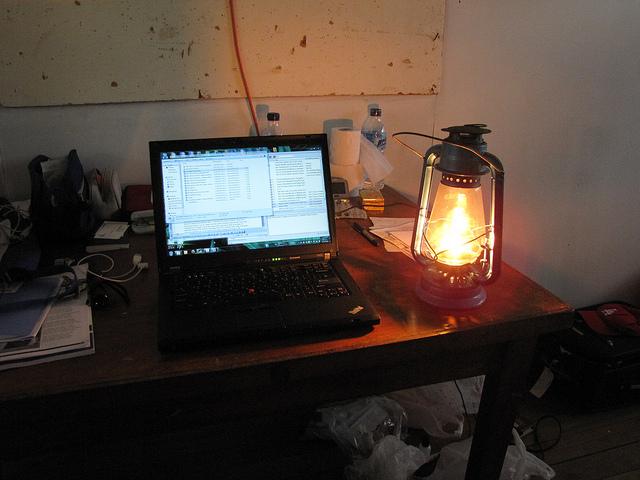Is the laptop on top of the table?
Keep it brief. Yes. How do you move the cursor on the laptop?
Keep it brief. Touchpad. What is given off light?
Answer briefly. Lantern. Is this a gas fire or burning wood?
Be succinct. Gas. 